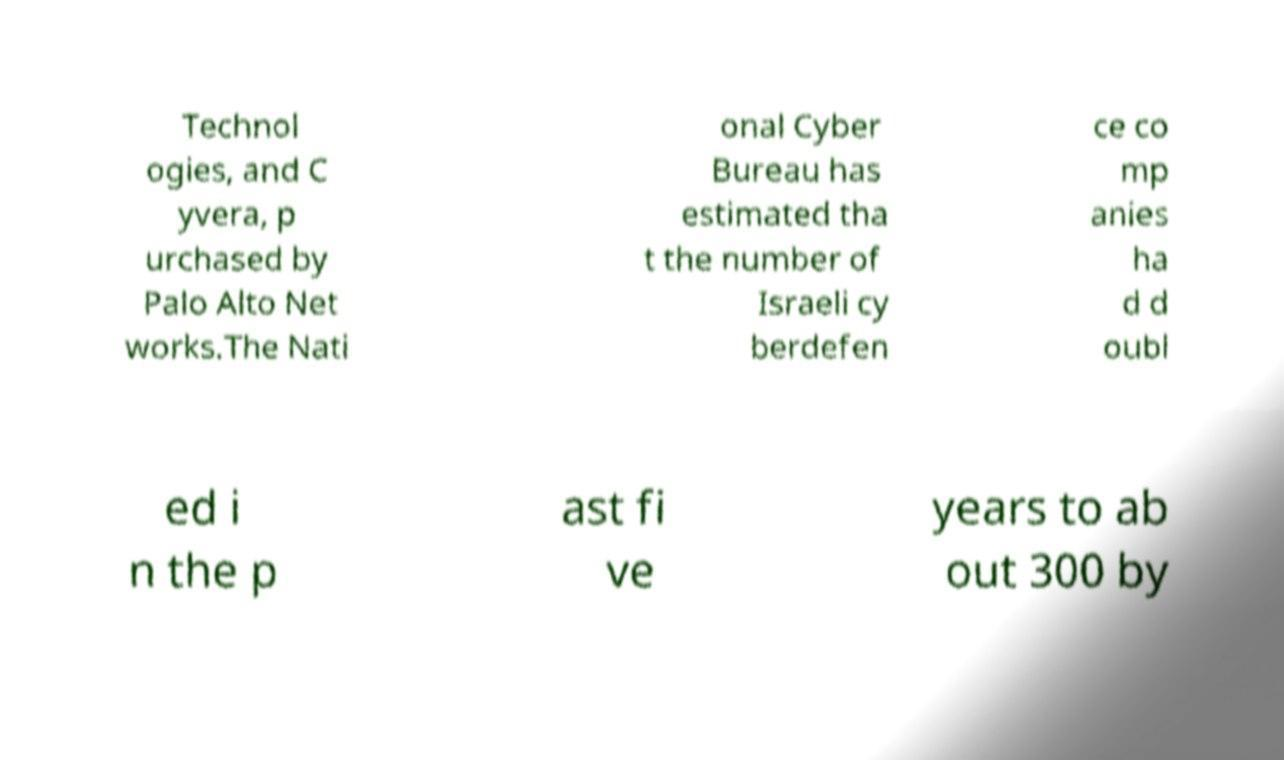Please identify and transcribe the text found in this image. Technol ogies, and C yvera, p urchased by Palo Alto Net works.The Nati onal Cyber Bureau has estimated tha t the number of Israeli cy berdefen ce co mp anies ha d d oubl ed i n the p ast fi ve years to ab out 300 by 